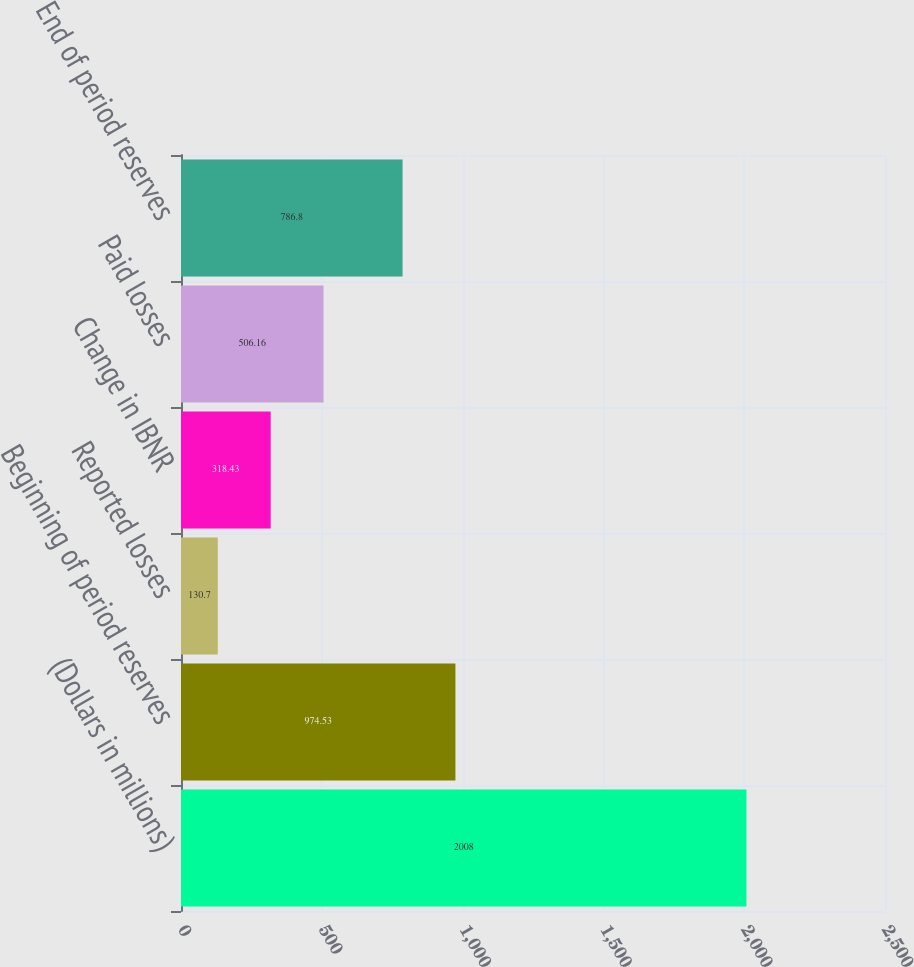Convert chart to OTSL. <chart><loc_0><loc_0><loc_500><loc_500><bar_chart><fcel>(Dollars in millions)<fcel>Beginning of period reserves<fcel>Reported losses<fcel>Change in IBNR<fcel>Paid losses<fcel>End of period reserves<nl><fcel>2008<fcel>974.53<fcel>130.7<fcel>318.43<fcel>506.16<fcel>786.8<nl></chart> 